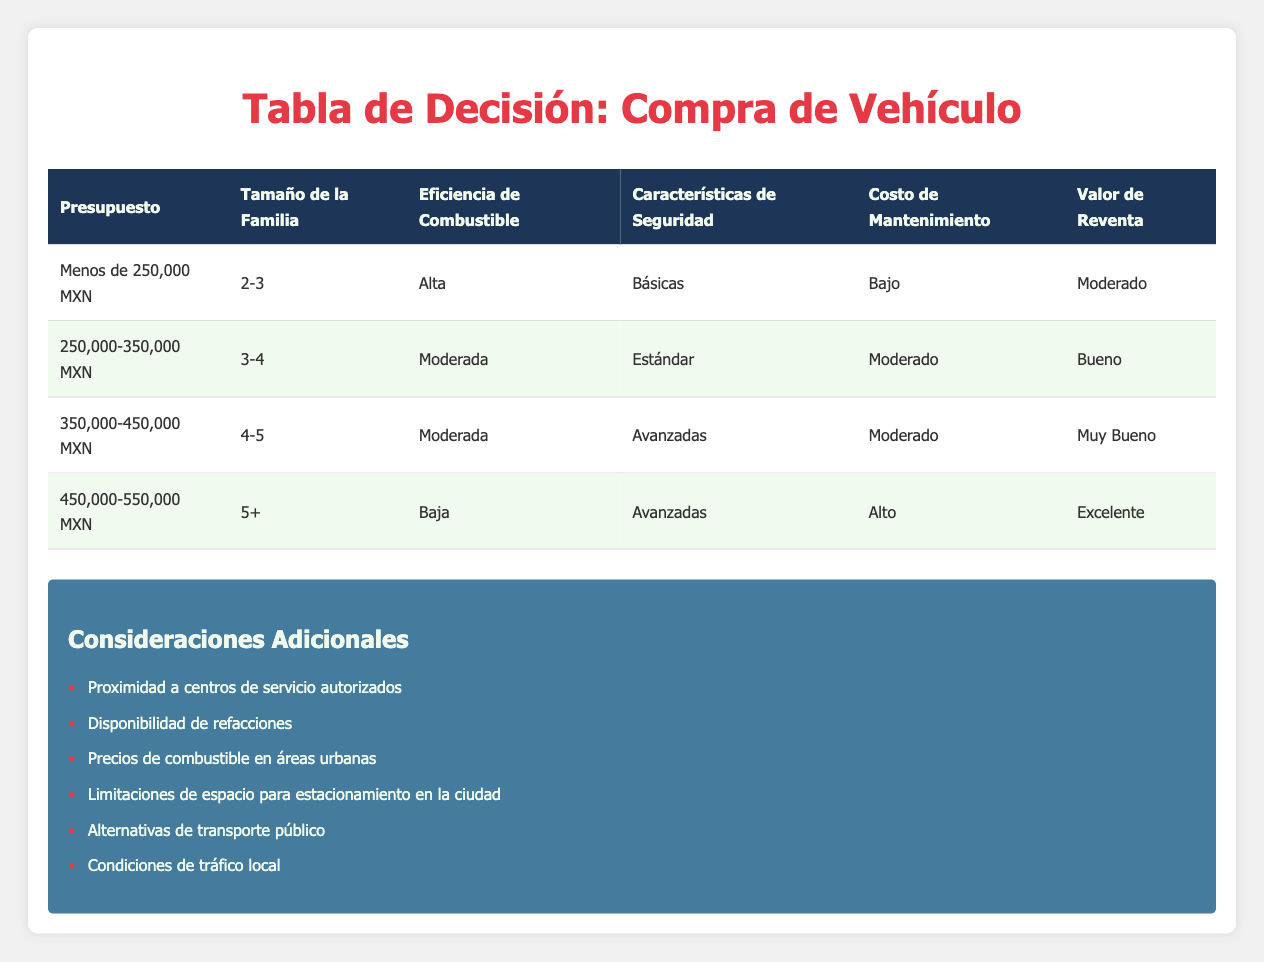What type of fuel efficiency does the Nissan Versa offer? According to the table, the Nissan Versa falls under the "Under 250,000 MXN" category, which indicates it has "High" fuel efficiency.
Answer: High Which vehicle option has advanced safety features for families with a size of 4-5? The table shows that for a family size of 4-5, the category with "Advanced" safety features is 350,000-450,000 MXN budget. The vehicle option available in that range is Chevrolet Aveo.
Answer: Chevrolet Aveo Is there a vehicle that offers low maintenance cost with basic safety features for a budget under 250,000 MXN? Yes, the Nissan Versa is listed under the budget of "Under 250,000 MXN" with a low maintenance cost and basic safety features.
Answer: Yes What is the resale value for a vehicle purchased in the budget of 250,000-350,000 MXN? The table indicates that for a budget of 250,000-350,000 MXN, the resale value is classified as "Good."
Answer: Good If a family has a budget of 450,000-550,000 MXN, what is the expected fuel efficiency? The table indicates that for a budget of 450,000-550,000 MXN, the fuel efficiency expected is "Low." This is found within the specified range for family size of 5 or more.
Answer: Low For families with more than 5 members and a budget of 450,000-550,000 MXN, which vehicle will have the best resale value? The table shows that under the budget of 450,000-550,000 MXN, the resale value is "Excellent," which applies to any vehicle option in that budget category. Therefore, it's necessary to compare options, but the data does not specify a vehicle better than others.
Answer: Excellent What is the average maintenance cost category across all budget ranges? The maintenance costs across the ranges are: "Low," "Moderate," "Moderate," and "High." To find the average category, we can assign values: Low (1), Moderate (2), High (3), yielding (1+2+2+3)/4 = 2, which corresponds to "Moderate."
Answer: Moderate Are features like safety and resale value standardized across different budget ranges? No, the table shows that as the budget increases, safety features generally improve from "Basic" to "Advanced" and the resale value increases from "Moderate" to "Excellent."
Answer: No 